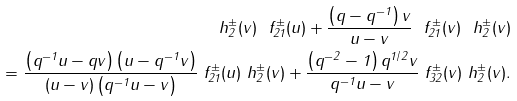<formula> <loc_0><loc_0><loc_500><loc_500>\ h ^ { \pm } _ { 2 } ( v ) \ f _ { 2 1 } ^ { \pm } ( u ) + \frac { \left ( q - q ^ { - 1 } \right ) v } { u - v } \ f ^ { \pm } _ { 2 1 } ( v ) \ h ^ { \pm } _ { 2 } ( v ) \\ = \frac { \left ( q ^ { - 1 } u - q v \right ) \left ( u - q ^ { - 1 } v \right ) } { ( u - v ) \left ( q ^ { - 1 } u - v \right ) } \ f ^ { \pm } _ { 2 1 } ( u ) \ h ^ { \pm } _ { 2 } ( v ) + \frac { \left ( q ^ { - 2 } - 1 \right ) q ^ { 1 / 2 } v } { q ^ { - 1 } u - v } \ f ^ { \pm } _ { 3 2 } ( v ) \ h ^ { \pm } _ { 2 } ( v ) .</formula> 